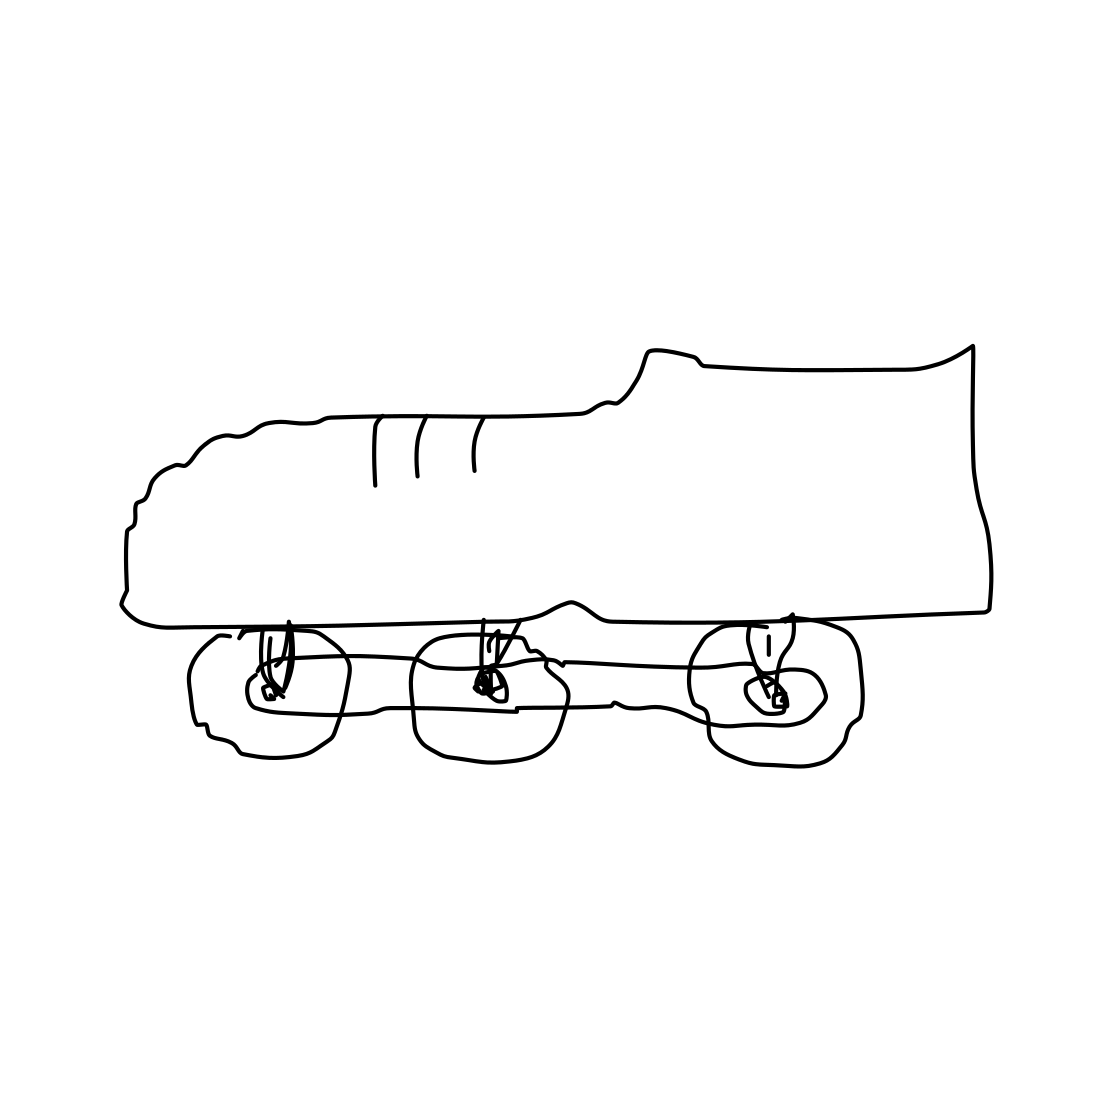Is this a snowman in the image? No, the image does not depict a snowman. Instead, it shows a drawing of a sneaker with rollerskates attached to its sole. 